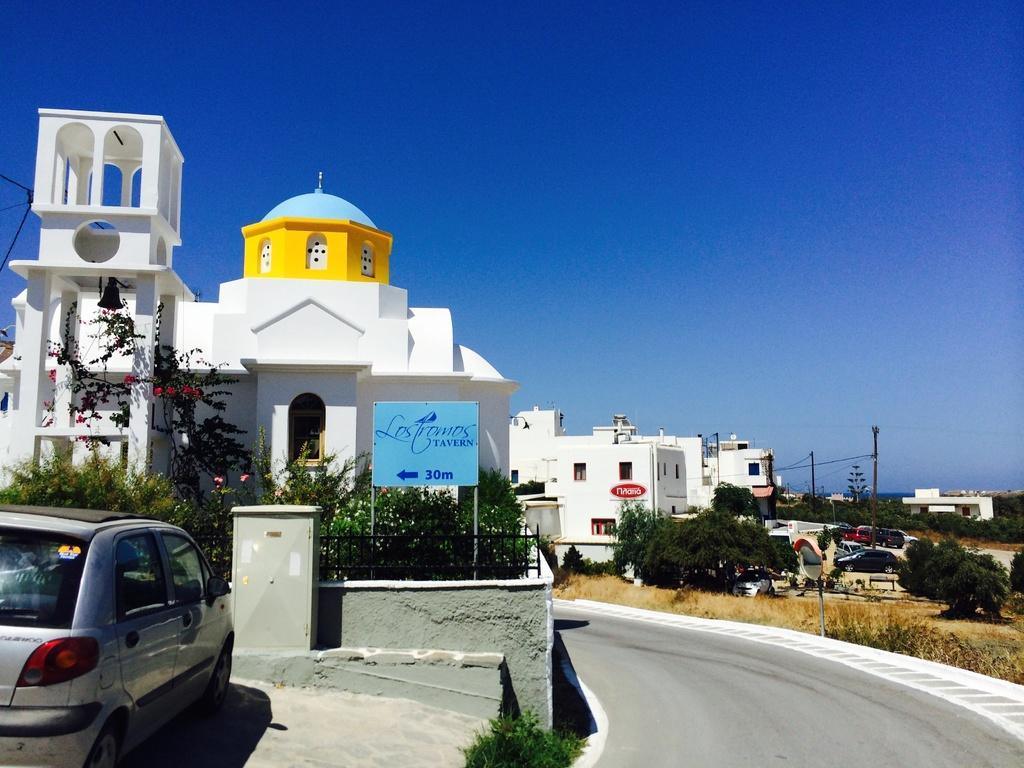Could you give a brief overview of what you see in this image? In this picture I can observe a building on the left side. There are some plants in the middle of the picture. On the right side there is a road. I can observe a car parked on the left side. In the background there is sky. 